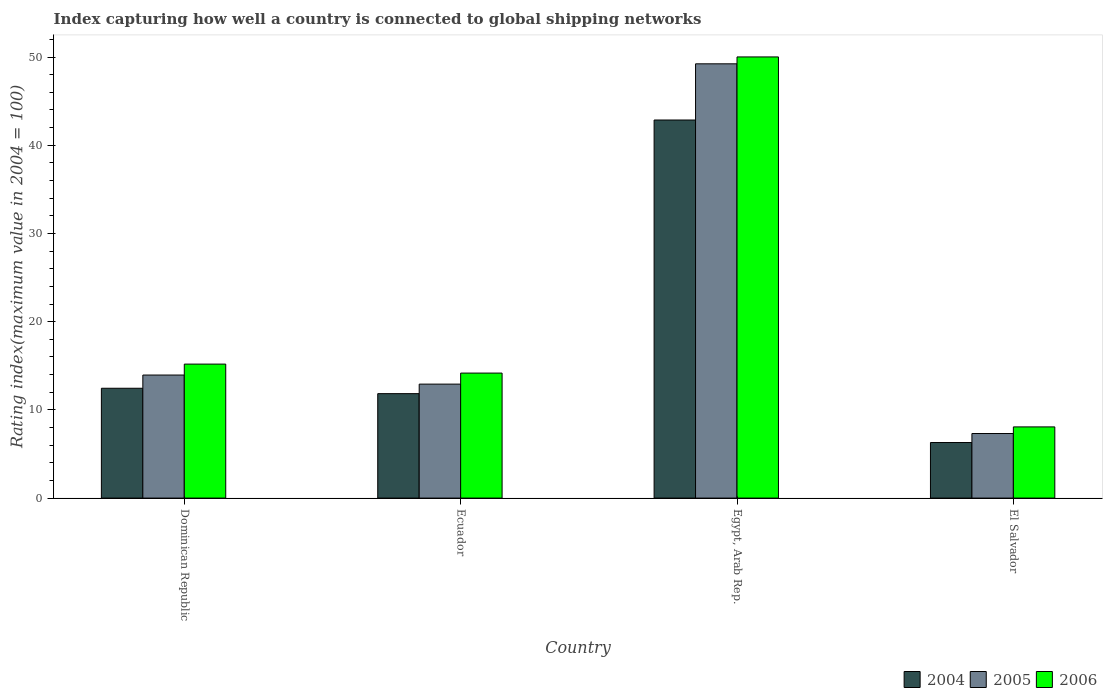How many different coloured bars are there?
Make the answer very short. 3. How many groups of bars are there?
Your answer should be compact. 4. Are the number of bars per tick equal to the number of legend labels?
Provide a succinct answer. Yes. How many bars are there on the 3rd tick from the left?
Offer a terse response. 3. What is the label of the 4th group of bars from the left?
Keep it short and to the point. El Salvador. What is the rating index in 2005 in Egypt, Arab Rep.?
Provide a short and direct response. 49.23. Across all countries, what is the maximum rating index in 2006?
Offer a very short reply. 50.01. Across all countries, what is the minimum rating index in 2005?
Ensure brevity in your answer.  7.32. In which country was the rating index in 2005 maximum?
Your answer should be very brief. Egypt, Arab Rep. In which country was the rating index in 2005 minimum?
Your answer should be very brief. El Salvador. What is the total rating index in 2006 in the graph?
Make the answer very short. 87.44. What is the difference between the rating index in 2006 in Dominican Republic and that in Egypt, Arab Rep.?
Your answer should be very brief. -34.82. What is the difference between the rating index in 2004 in El Salvador and the rating index in 2005 in Ecuador?
Make the answer very short. -6.62. What is the average rating index in 2006 per country?
Ensure brevity in your answer.  21.86. What is the difference between the rating index of/in 2006 and rating index of/in 2004 in Dominican Republic?
Provide a succinct answer. 2.74. What is the ratio of the rating index in 2005 in Dominican Republic to that in El Salvador?
Your answer should be compact. 1.91. Is the difference between the rating index in 2006 in Dominican Republic and Ecuador greater than the difference between the rating index in 2004 in Dominican Republic and Ecuador?
Provide a short and direct response. Yes. What is the difference between the highest and the second highest rating index in 2006?
Your response must be concise. 35.84. What is the difference between the highest and the lowest rating index in 2006?
Make the answer very short. 41.94. In how many countries, is the rating index in 2004 greater than the average rating index in 2004 taken over all countries?
Your answer should be compact. 1. What does the 2nd bar from the left in Dominican Republic represents?
Your answer should be compact. 2005. What does the 1st bar from the right in El Salvador represents?
Keep it short and to the point. 2006. Is it the case that in every country, the sum of the rating index in 2006 and rating index in 2005 is greater than the rating index in 2004?
Your answer should be very brief. Yes. How many bars are there?
Your answer should be compact. 12. Are all the bars in the graph horizontal?
Your response must be concise. No. How many countries are there in the graph?
Ensure brevity in your answer.  4. Does the graph contain any zero values?
Your answer should be compact. No. How many legend labels are there?
Give a very brief answer. 3. How are the legend labels stacked?
Make the answer very short. Horizontal. What is the title of the graph?
Give a very brief answer. Index capturing how well a country is connected to global shipping networks. Does "1980" appear as one of the legend labels in the graph?
Your answer should be very brief. No. What is the label or title of the Y-axis?
Your answer should be very brief. Rating index(maximum value in 2004 = 100). What is the Rating index(maximum value in 2004 = 100) in 2004 in Dominican Republic?
Your response must be concise. 12.45. What is the Rating index(maximum value in 2004 = 100) in 2005 in Dominican Republic?
Give a very brief answer. 13.95. What is the Rating index(maximum value in 2004 = 100) in 2006 in Dominican Republic?
Your response must be concise. 15.19. What is the Rating index(maximum value in 2004 = 100) in 2004 in Ecuador?
Offer a terse response. 11.84. What is the Rating index(maximum value in 2004 = 100) in 2005 in Ecuador?
Ensure brevity in your answer.  12.92. What is the Rating index(maximum value in 2004 = 100) in 2006 in Ecuador?
Provide a short and direct response. 14.17. What is the Rating index(maximum value in 2004 = 100) in 2004 in Egypt, Arab Rep.?
Keep it short and to the point. 42.86. What is the Rating index(maximum value in 2004 = 100) in 2005 in Egypt, Arab Rep.?
Give a very brief answer. 49.23. What is the Rating index(maximum value in 2004 = 100) in 2006 in Egypt, Arab Rep.?
Make the answer very short. 50.01. What is the Rating index(maximum value in 2004 = 100) in 2004 in El Salvador?
Make the answer very short. 6.3. What is the Rating index(maximum value in 2004 = 100) in 2005 in El Salvador?
Ensure brevity in your answer.  7.32. What is the Rating index(maximum value in 2004 = 100) of 2006 in El Salvador?
Offer a terse response. 8.07. Across all countries, what is the maximum Rating index(maximum value in 2004 = 100) in 2004?
Your answer should be very brief. 42.86. Across all countries, what is the maximum Rating index(maximum value in 2004 = 100) of 2005?
Keep it short and to the point. 49.23. Across all countries, what is the maximum Rating index(maximum value in 2004 = 100) in 2006?
Your answer should be compact. 50.01. Across all countries, what is the minimum Rating index(maximum value in 2004 = 100) of 2004?
Keep it short and to the point. 6.3. Across all countries, what is the minimum Rating index(maximum value in 2004 = 100) in 2005?
Provide a short and direct response. 7.32. Across all countries, what is the minimum Rating index(maximum value in 2004 = 100) of 2006?
Your answer should be very brief. 8.07. What is the total Rating index(maximum value in 2004 = 100) of 2004 in the graph?
Offer a very short reply. 73.45. What is the total Rating index(maximum value in 2004 = 100) in 2005 in the graph?
Make the answer very short. 83.42. What is the total Rating index(maximum value in 2004 = 100) of 2006 in the graph?
Keep it short and to the point. 87.44. What is the difference between the Rating index(maximum value in 2004 = 100) of 2004 in Dominican Republic and that in Ecuador?
Give a very brief answer. 0.61. What is the difference between the Rating index(maximum value in 2004 = 100) in 2006 in Dominican Republic and that in Ecuador?
Keep it short and to the point. 1.02. What is the difference between the Rating index(maximum value in 2004 = 100) of 2004 in Dominican Republic and that in Egypt, Arab Rep.?
Offer a terse response. -30.41. What is the difference between the Rating index(maximum value in 2004 = 100) in 2005 in Dominican Republic and that in Egypt, Arab Rep.?
Provide a short and direct response. -35.28. What is the difference between the Rating index(maximum value in 2004 = 100) in 2006 in Dominican Republic and that in Egypt, Arab Rep.?
Keep it short and to the point. -34.82. What is the difference between the Rating index(maximum value in 2004 = 100) of 2004 in Dominican Republic and that in El Salvador?
Offer a terse response. 6.15. What is the difference between the Rating index(maximum value in 2004 = 100) of 2005 in Dominican Republic and that in El Salvador?
Keep it short and to the point. 6.63. What is the difference between the Rating index(maximum value in 2004 = 100) in 2006 in Dominican Republic and that in El Salvador?
Give a very brief answer. 7.12. What is the difference between the Rating index(maximum value in 2004 = 100) in 2004 in Ecuador and that in Egypt, Arab Rep.?
Your answer should be compact. -31.02. What is the difference between the Rating index(maximum value in 2004 = 100) in 2005 in Ecuador and that in Egypt, Arab Rep.?
Ensure brevity in your answer.  -36.31. What is the difference between the Rating index(maximum value in 2004 = 100) of 2006 in Ecuador and that in Egypt, Arab Rep.?
Your answer should be compact. -35.84. What is the difference between the Rating index(maximum value in 2004 = 100) of 2004 in Ecuador and that in El Salvador?
Your answer should be very brief. 5.54. What is the difference between the Rating index(maximum value in 2004 = 100) of 2006 in Ecuador and that in El Salvador?
Make the answer very short. 6.1. What is the difference between the Rating index(maximum value in 2004 = 100) in 2004 in Egypt, Arab Rep. and that in El Salvador?
Provide a succinct answer. 36.56. What is the difference between the Rating index(maximum value in 2004 = 100) of 2005 in Egypt, Arab Rep. and that in El Salvador?
Provide a short and direct response. 41.91. What is the difference between the Rating index(maximum value in 2004 = 100) of 2006 in Egypt, Arab Rep. and that in El Salvador?
Provide a succinct answer. 41.94. What is the difference between the Rating index(maximum value in 2004 = 100) in 2004 in Dominican Republic and the Rating index(maximum value in 2004 = 100) in 2005 in Ecuador?
Provide a short and direct response. -0.47. What is the difference between the Rating index(maximum value in 2004 = 100) of 2004 in Dominican Republic and the Rating index(maximum value in 2004 = 100) of 2006 in Ecuador?
Provide a succinct answer. -1.72. What is the difference between the Rating index(maximum value in 2004 = 100) of 2005 in Dominican Republic and the Rating index(maximum value in 2004 = 100) of 2006 in Ecuador?
Offer a very short reply. -0.22. What is the difference between the Rating index(maximum value in 2004 = 100) of 2004 in Dominican Republic and the Rating index(maximum value in 2004 = 100) of 2005 in Egypt, Arab Rep.?
Your answer should be compact. -36.78. What is the difference between the Rating index(maximum value in 2004 = 100) in 2004 in Dominican Republic and the Rating index(maximum value in 2004 = 100) in 2006 in Egypt, Arab Rep.?
Your answer should be compact. -37.56. What is the difference between the Rating index(maximum value in 2004 = 100) in 2005 in Dominican Republic and the Rating index(maximum value in 2004 = 100) in 2006 in Egypt, Arab Rep.?
Your response must be concise. -36.06. What is the difference between the Rating index(maximum value in 2004 = 100) of 2004 in Dominican Republic and the Rating index(maximum value in 2004 = 100) of 2005 in El Salvador?
Give a very brief answer. 5.13. What is the difference between the Rating index(maximum value in 2004 = 100) of 2004 in Dominican Republic and the Rating index(maximum value in 2004 = 100) of 2006 in El Salvador?
Offer a terse response. 4.38. What is the difference between the Rating index(maximum value in 2004 = 100) in 2005 in Dominican Republic and the Rating index(maximum value in 2004 = 100) in 2006 in El Salvador?
Your answer should be very brief. 5.88. What is the difference between the Rating index(maximum value in 2004 = 100) in 2004 in Ecuador and the Rating index(maximum value in 2004 = 100) in 2005 in Egypt, Arab Rep.?
Offer a terse response. -37.39. What is the difference between the Rating index(maximum value in 2004 = 100) of 2004 in Ecuador and the Rating index(maximum value in 2004 = 100) of 2006 in Egypt, Arab Rep.?
Keep it short and to the point. -38.17. What is the difference between the Rating index(maximum value in 2004 = 100) in 2005 in Ecuador and the Rating index(maximum value in 2004 = 100) in 2006 in Egypt, Arab Rep.?
Your response must be concise. -37.09. What is the difference between the Rating index(maximum value in 2004 = 100) of 2004 in Ecuador and the Rating index(maximum value in 2004 = 100) of 2005 in El Salvador?
Provide a succinct answer. 4.52. What is the difference between the Rating index(maximum value in 2004 = 100) of 2004 in Ecuador and the Rating index(maximum value in 2004 = 100) of 2006 in El Salvador?
Your answer should be very brief. 3.77. What is the difference between the Rating index(maximum value in 2004 = 100) in 2005 in Ecuador and the Rating index(maximum value in 2004 = 100) in 2006 in El Salvador?
Give a very brief answer. 4.85. What is the difference between the Rating index(maximum value in 2004 = 100) of 2004 in Egypt, Arab Rep. and the Rating index(maximum value in 2004 = 100) of 2005 in El Salvador?
Provide a short and direct response. 35.54. What is the difference between the Rating index(maximum value in 2004 = 100) in 2004 in Egypt, Arab Rep. and the Rating index(maximum value in 2004 = 100) in 2006 in El Salvador?
Make the answer very short. 34.79. What is the difference between the Rating index(maximum value in 2004 = 100) in 2005 in Egypt, Arab Rep. and the Rating index(maximum value in 2004 = 100) in 2006 in El Salvador?
Provide a succinct answer. 41.16. What is the average Rating index(maximum value in 2004 = 100) of 2004 per country?
Give a very brief answer. 18.36. What is the average Rating index(maximum value in 2004 = 100) in 2005 per country?
Offer a very short reply. 20.86. What is the average Rating index(maximum value in 2004 = 100) in 2006 per country?
Your response must be concise. 21.86. What is the difference between the Rating index(maximum value in 2004 = 100) in 2004 and Rating index(maximum value in 2004 = 100) in 2005 in Dominican Republic?
Offer a terse response. -1.5. What is the difference between the Rating index(maximum value in 2004 = 100) in 2004 and Rating index(maximum value in 2004 = 100) in 2006 in Dominican Republic?
Provide a succinct answer. -2.74. What is the difference between the Rating index(maximum value in 2004 = 100) in 2005 and Rating index(maximum value in 2004 = 100) in 2006 in Dominican Republic?
Your response must be concise. -1.24. What is the difference between the Rating index(maximum value in 2004 = 100) of 2004 and Rating index(maximum value in 2004 = 100) of 2005 in Ecuador?
Your response must be concise. -1.08. What is the difference between the Rating index(maximum value in 2004 = 100) in 2004 and Rating index(maximum value in 2004 = 100) in 2006 in Ecuador?
Offer a terse response. -2.33. What is the difference between the Rating index(maximum value in 2004 = 100) in 2005 and Rating index(maximum value in 2004 = 100) in 2006 in Ecuador?
Your response must be concise. -1.25. What is the difference between the Rating index(maximum value in 2004 = 100) of 2004 and Rating index(maximum value in 2004 = 100) of 2005 in Egypt, Arab Rep.?
Give a very brief answer. -6.37. What is the difference between the Rating index(maximum value in 2004 = 100) of 2004 and Rating index(maximum value in 2004 = 100) of 2006 in Egypt, Arab Rep.?
Provide a short and direct response. -7.15. What is the difference between the Rating index(maximum value in 2004 = 100) in 2005 and Rating index(maximum value in 2004 = 100) in 2006 in Egypt, Arab Rep.?
Your answer should be compact. -0.78. What is the difference between the Rating index(maximum value in 2004 = 100) in 2004 and Rating index(maximum value in 2004 = 100) in 2005 in El Salvador?
Provide a short and direct response. -1.02. What is the difference between the Rating index(maximum value in 2004 = 100) of 2004 and Rating index(maximum value in 2004 = 100) of 2006 in El Salvador?
Keep it short and to the point. -1.77. What is the difference between the Rating index(maximum value in 2004 = 100) of 2005 and Rating index(maximum value in 2004 = 100) of 2006 in El Salvador?
Keep it short and to the point. -0.75. What is the ratio of the Rating index(maximum value in 2004 = 100) of 2004 in Dominican Republic to that in Ecuador?
Make the answer very short. 1.05. What is the ratio of the Rating index(maximum value in 2004 = 100) of 2005 in Dominican Republic to that in Ecuador?
Your answer should be very brief. 1.08. What is the ratio of the Rating index(maximum value in 2004 = 100) of 2006 in Dominican Republic to that in Ecuador?
Your response must be concise. 1.07. What is the ratio of the Rating index(maximum value in 2004 = 100) of 2004 in Dominican Republic to that in Egypt, Arab Rep.?
Make the answer very short. 0.29. What is the ratio of the Rating index(maximum value in 2004 = 100) of 2005 in Dominican Republic to that in Egypt, Arab Rep.?
Your answer should be very brief. 0.28. What is the ratio of the Rating index(maximum value in 2004 = 100) of 2006 in Dominican Republic to that in Egypt, Arab Rep.?
Ensure brevity in your answer.  0.3. What is the ratio of the Rating index(maximum value in 2004 = 100) in 2004 in Dominican Republic to that in El Salvador?
Your answer should be compact. 1.98. What is the ratio of the Rating index(maximum value in 2004 = 100) in 2005 in Dominican Republic to that in El Salvador?
Keep it short and to the point. 1.91. What is the ratio of the Rating index(maximum value in 2004 = 100) in 2006 in Dominican Republic to that in El Salvador?
Provide a succinct answer. 1.88. What is the ratio of the Rating index(maximum value in 2004 = 100) of 2004 in Ecuador to that in Egypt, Arab Rep.?
Provide a succinct answer. 0.28. What is the ratio of the Rating index(maximum value in 2004 = 100) of 2005 in Ecuador to that in Egypt, Arab Rep.?
Your answer should be compact. 0.26. What is the ratio of the Rating index(maximum value in 2004 = 100) of 2006 in Ecuador to that in Egypt, Arab Rep.?
Your response must be concise. 0.28. What is the ratio of the Rating index(maximum value in 2004 = 100) in 2004 in Ecuador to that in El Salvador?
Ensure brevity in your answer.  1.88. What is the ratio of the Rating index(maximum value in 2004 = 100) of 2005 in Ecuador to that in El Salvador?
Provide a succinct answer. 1.76. What is the ratio of the Rating index(maximum value in 2004 = 100) in 2006 in Ecuador to that in El Salvador?
Ensure brevity in your answer.  1.76. What is the ratio of the Rating index(maximum value in 2004 = 100) in 2004 in Egypt, Arab Rep. to that in El Salvador?
Your answer should be compact. 6.8. What is the ratio of the Rating index(maximum value in 2004 = 100) in 2005 in Egypt, Arab Rep. to that in El Salvador?
Provide a short and direct response. 6.73. What is the ratio of the Rating index(maximum value in 2004 = 100) of 2006 in Egypt, Arab Rep. to that in El Salvador?
Offer a very short reply. 6.2. What is the difference between the highest and the second highest Rating index(maximum value in 2004 = 100) of 2004?
Offer a very short reply. 30.41. What is the difference between the highest and the second highest Rating index(maximum value in 2004 = 100) of 2005?
Offer a very short reply. 35.28. What is the difference between the highest and the second highest Rating index(maximum value in 2004 = 100) of 2006?
Give a very brief answer. 34.82. What is the difference between the highest and the lowest Rating index(maximum value in 2004 = 100) of 2004?
Provide a short and direct response. 36.56. What is the difference between the highest and the lowest Rating index(maximum value in 2004 = 100) of 2005?
Ensure brevity in your answer.  41.91. What is the difference between the highest and the lowest Rating index(maximum value in 2004 = 100) in 2006?
Offer a very short reply. 41.94. 